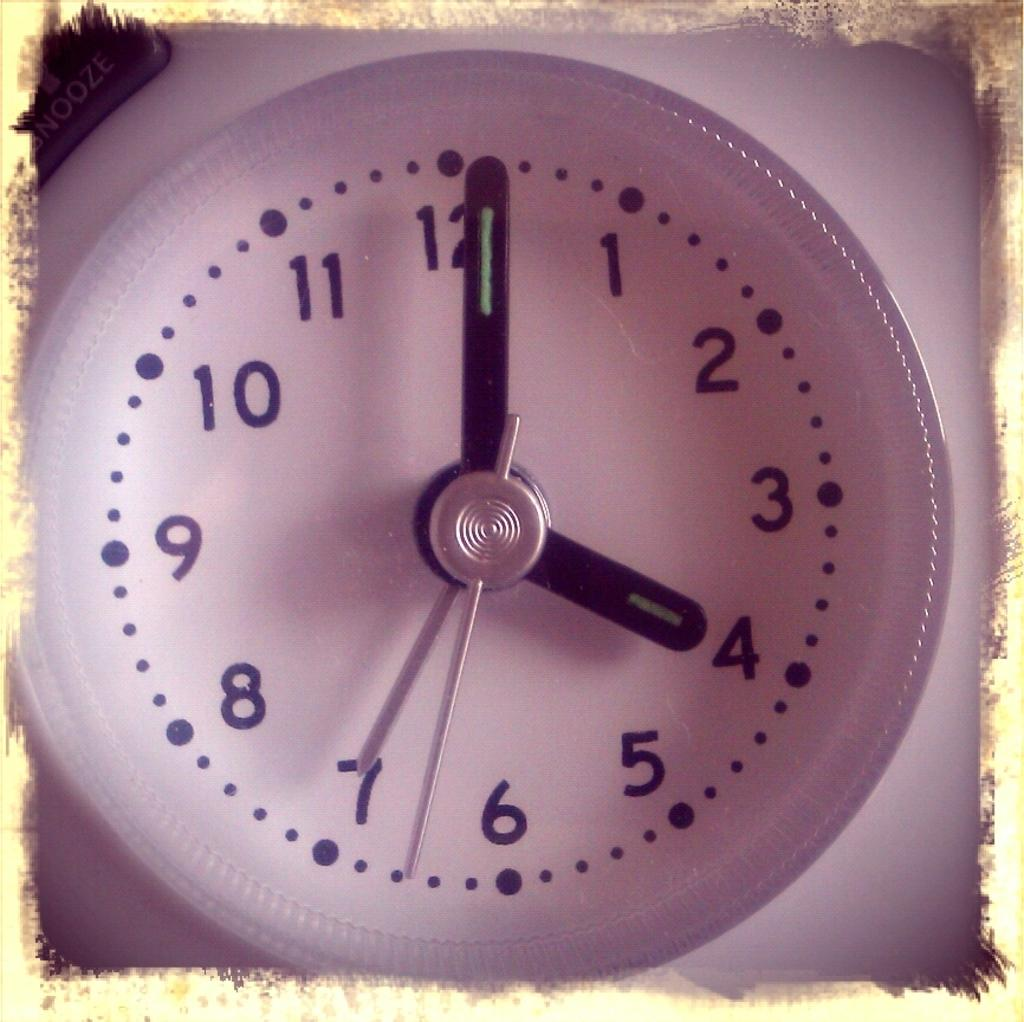Provide a one-sentence caption for the provided image. The white clock shows that it is just past 4 o'clock. 